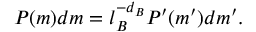Convert formula to latex. <formula><loc_0><loc_0><loc_500><loc_500>P ( m ) d m = l _ { B } ^ { - d _ { B } } P ^ { \prime } ( m ^ { \prime } ) d m ^ { \prime } .</formula> 